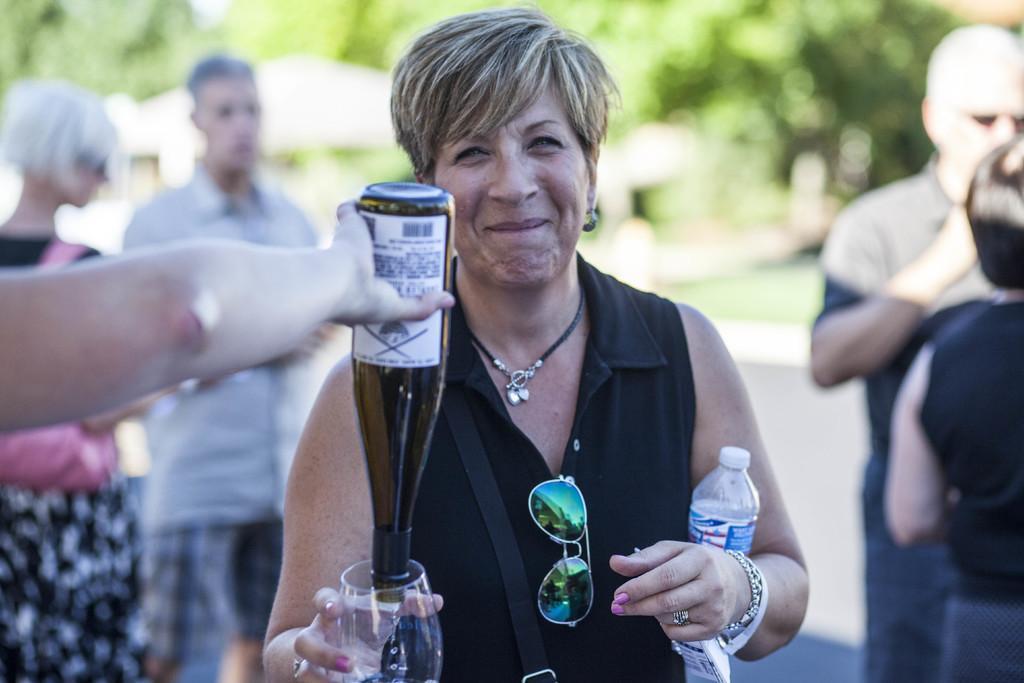How would you summarize this image in a sentence or two? In this image I see a woman who is smiling and she is holding a bottle and glass. I can also see there is another person's hand and I see the person is holding a bottle. In the background I see 4 persons. 